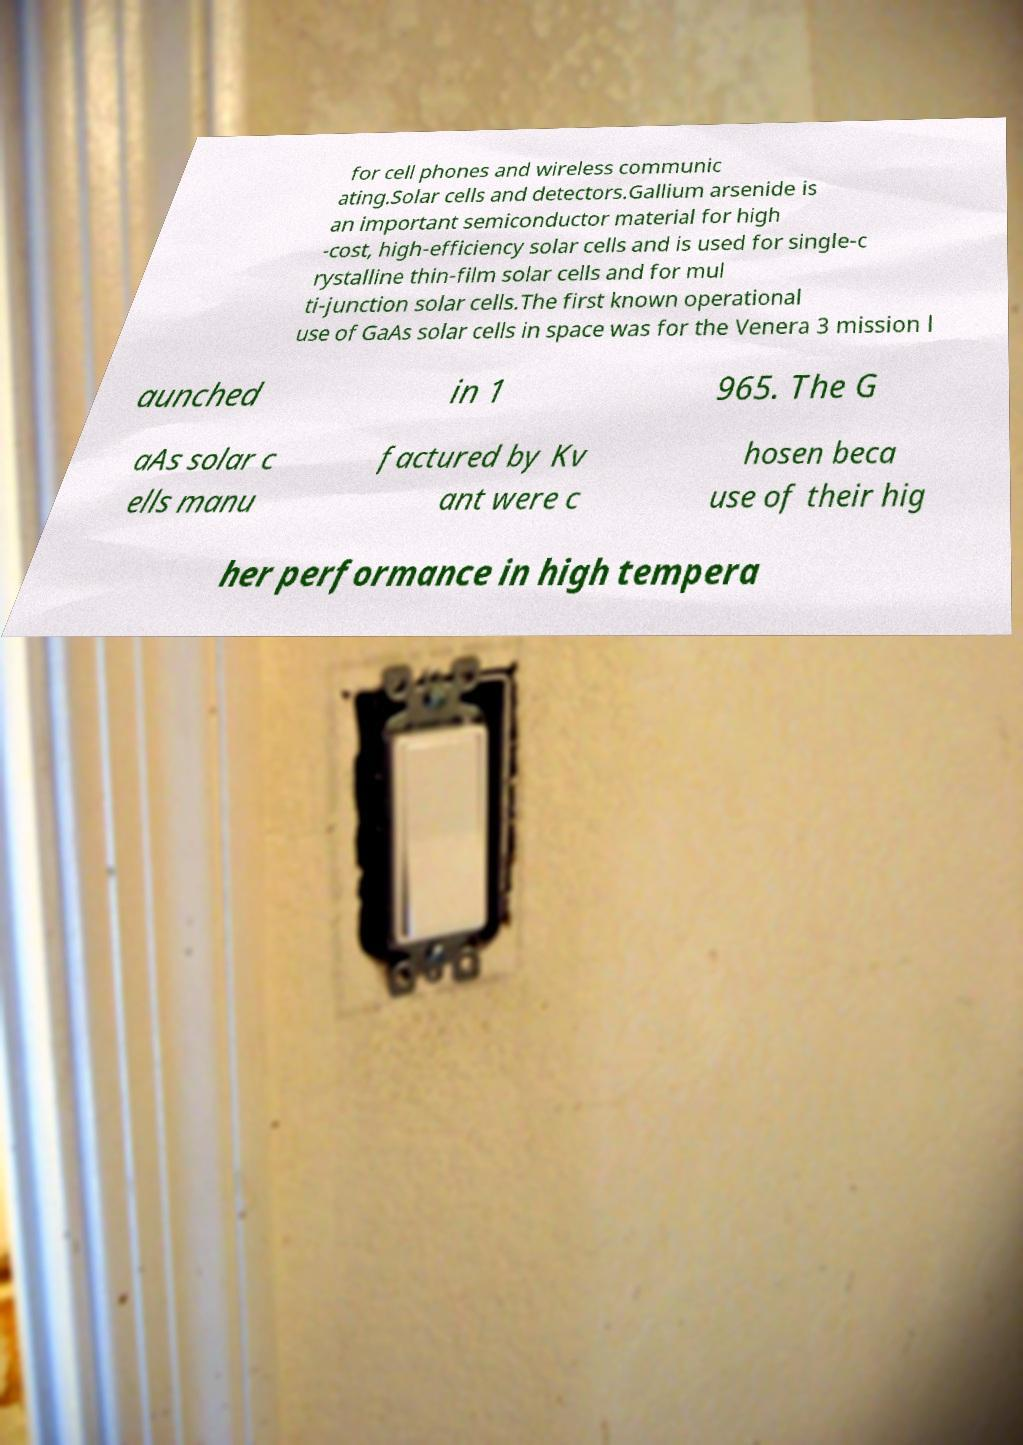Can you accurately transcribe the text from the provided image for me? for cell phones and wireless communic ating.Solar cells and detectors.Gallium arsenide is an important semiconductor material for high -cost, high-efficiency solar cells and is used for single-c rystalline thin-film solar cells and for mul ti-junction solar cells.The first known operational use of GaAs solar cells in space was for the Venera 3 mission l aunched in 1 965. The G aAs solar c ells manu factured by Kv ant were c hosen beca use of their hig her performance in high tempera 